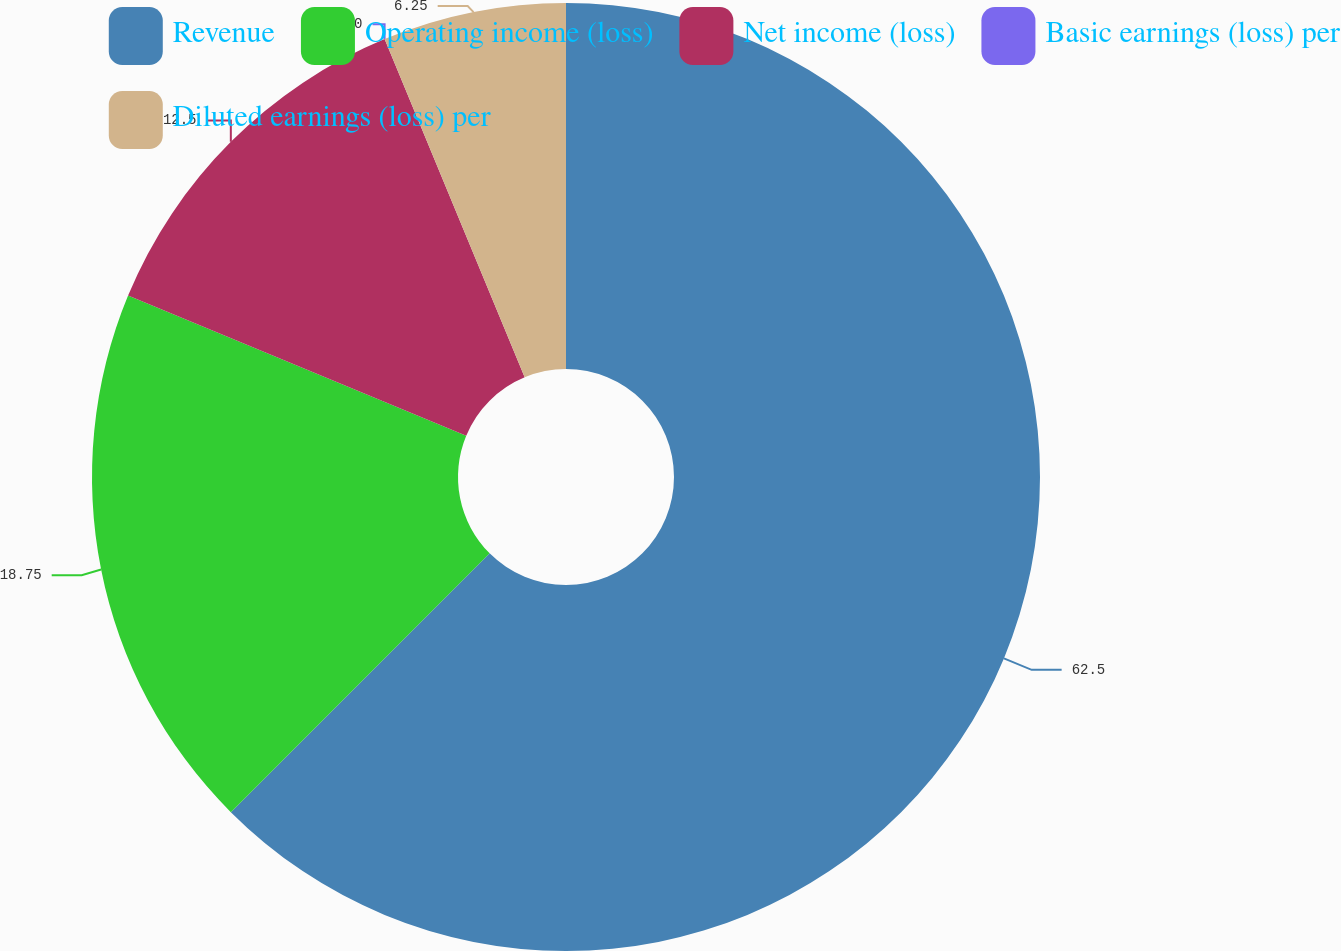Convert chart. <chart><loc_0><loc_0><loc_500><loc_500><pie_chart><fcel>Revenue<fcel>Operating income (loss)<fcel>Net income (loss)<fcel>Basic earnings (loss) per<fcel>Diluted earnings (loss) per<nl><fcel>62.5%<fcel>18.75%<fcel>12.5%<fcel>0.0%<fcel>6.25%<nl></chart> 